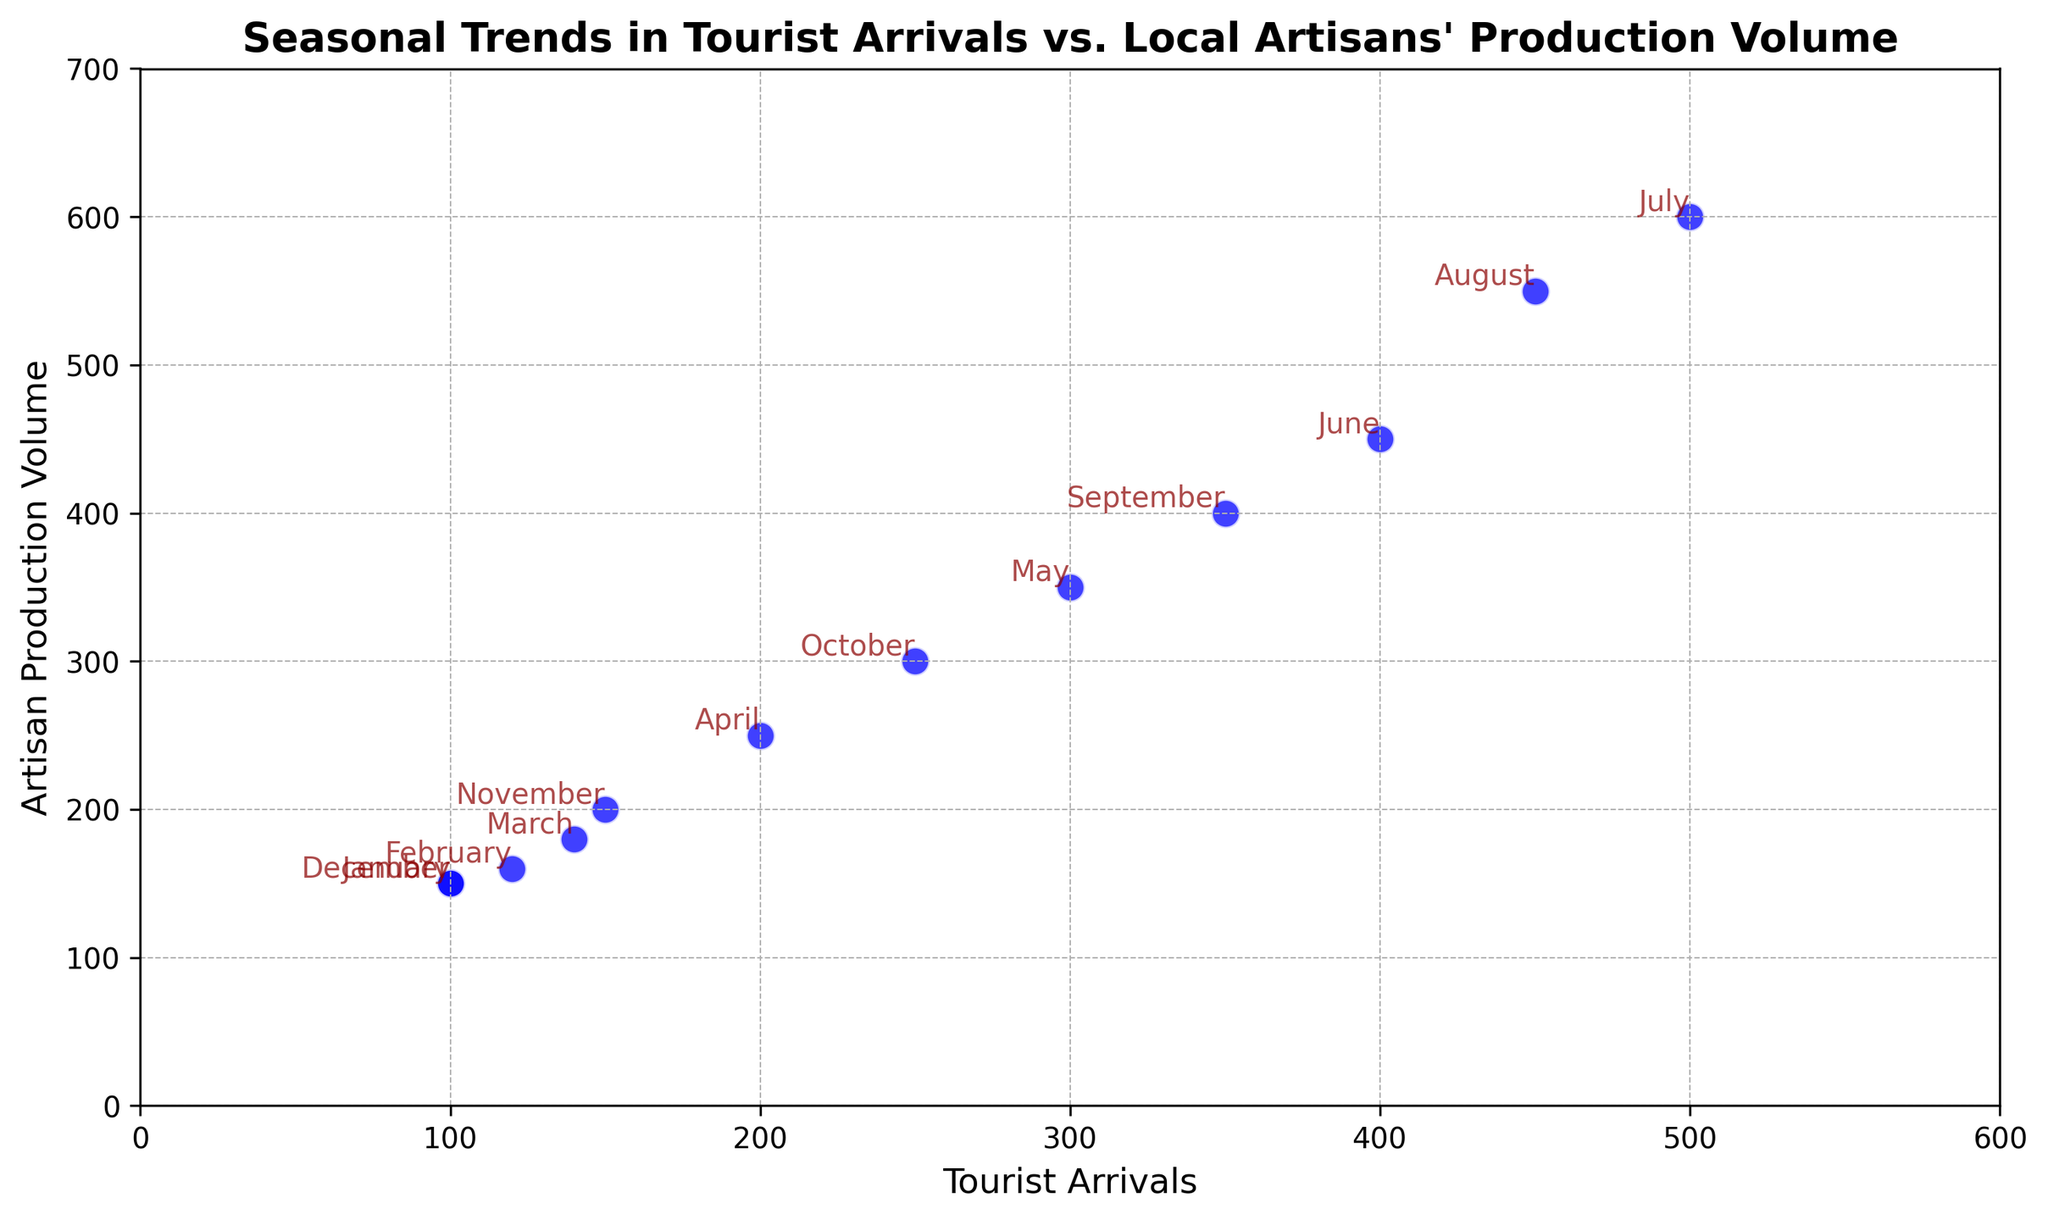What month has the highest tourist arrivals? The point with the highest value on the x-axis represents July. Annotating the scatter plot further confirms this.
Answer: July Is there a month where the tourist arrivals and artisan production volume are exactly equal? Each point represents a month, and none of the points fall on the diagonal line where x (tourist arrivals) is equal to y (artisan production volume).
Answer: No Which month shows the largest gap between tourist arrivals and artisan production volume? By comparing the x and y values, July shows the largest difference with 500 tourist arrivals and 600 artisan production volumes, creating a gap of 100.
Answer: July Does an increase in tourist arrivals always result in an increase in artisan production volume? By examining the pattern, as tourist arrivals increase from January to July, artisan production volumes also rise. From July to December, both decrease. There’s a consistent trend.
Answer: Yes In which month are both tourist arrivals and artisan production volume the lowest? The lowest points on both the x and y axes are in January and December with values of 100 for tourist arrivals and 150 for production volume. Confirmation can be done by annotating.
Answer: January and December What is the difference in tourist arrivals between April and October? From the scatter plot, the x-value for April is 200 and for October is 250. The difference is 50.
Answer: 50 Which has a steeper increase: tourist arrivals from March to April or artisan production volume from February to March? From March to April, tourist arrivals increase from 140 to 200, a difference of 60. From February to March, production volume increases from 160 to 180, a difference of 20. The increase in tourist arrivals is steeper.
Answer: Tourist arrivals from March to April What are the tourist arrivals and artisan production volume values for June? The point for June can be found by annotating, with values of 400 for tourist arrivals and 450 for artisan production volume.
Answer: 400 and 450 Do any two consecutive months have the same change in both tourist arrivals and artisan production volume? By checking the changes month-to-month, noticeable patterns show the same change. From January to February, the change in both tourist arrivals and artisan production volume is consistent.
Answer: Yes, January to February How does the trend of tourist arrivals in the first half of the year compare to the second half? In the scatter plot, the trend in the first half (January to June) shows an increase in both tourist arrivals and artisan production volume. The second half (July to December) depicts a decrease corresponding with the points’ distribution.
Answer: Increase in the first half, decrease in the second half 